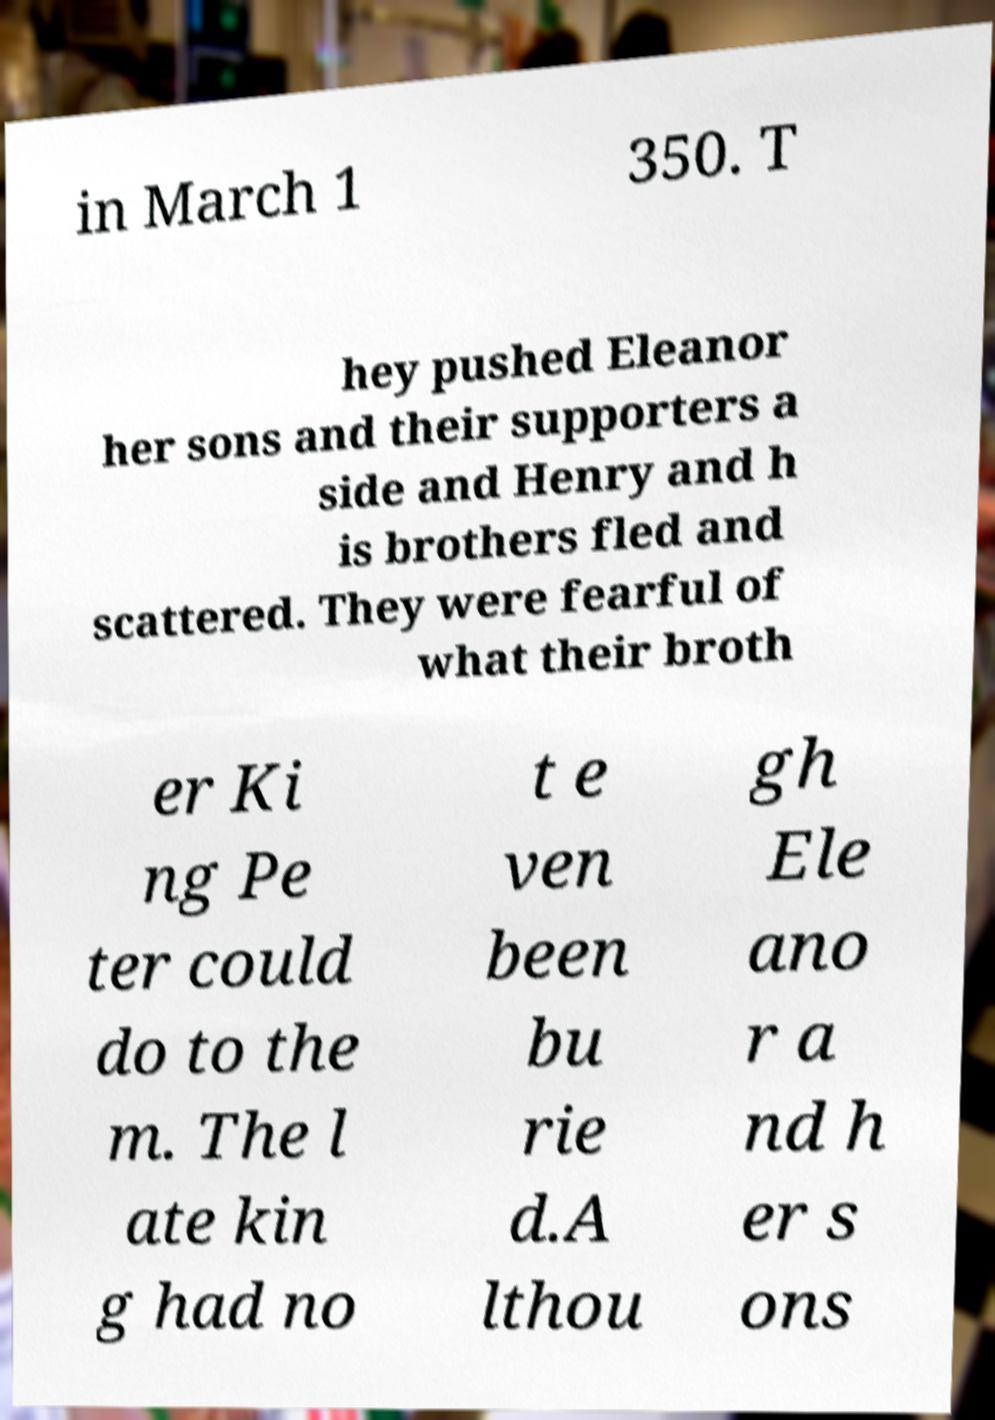Could you extract and type out the text from this image? in March 1 350. T hey pushed Eleanor her sons and their supporters a side and Henry and h is brothers fled and scattered. They were fearful of what their broth er Ki ng Pe ter could do to the m. The l ate kin g had no t e ven been bu rie d.A lthou gh Ele ano r a nd h er s ons 